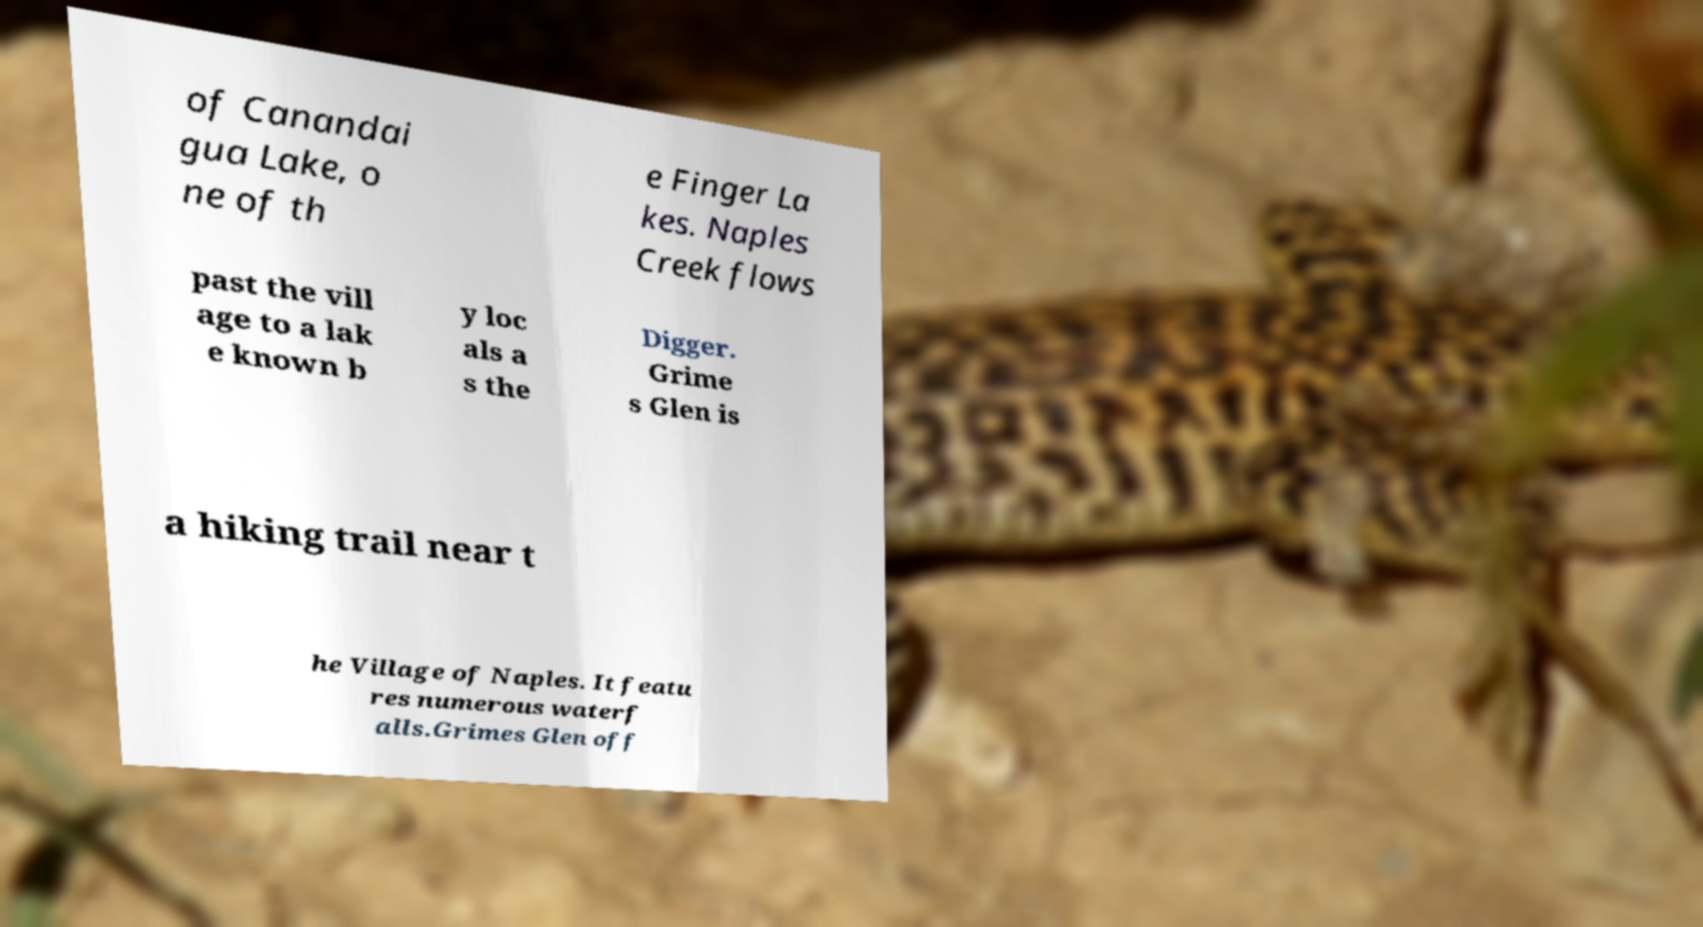I need the written content from this picture converted into text. Can you do that? of Canandai gua Lake, o ne of th e Finger La kes. Naples Creek flows past the vill age to a lak e known b y loc als a s the Digger. Grime s Glen is a hiking trail near t he Village of Naples. It featu res numerous waterf alls.Grimes Glen off 